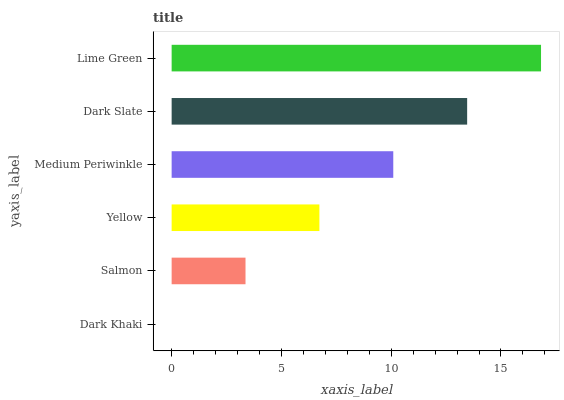Is Dark Khaki the minimum?
Answer yes or no. Yes. Is Lime Green the maximum?
Answer yes or no. Yes. Is Salmon the minimum?
Answer yes or no. No. Is Salmon the maximum?
Answer yes or no. No. Is Salmon greater than Dark Khaki?
Answer yes or no. Yes. Is Dark Khaki less than Salmon?
Answer yes or no. Yes. Is Dark Khaki greater than Salmon?
Answer yes or no. No. Is Salmon less than Dark Khaki?
Answer yes or no. No. Is Medium Periwinkle the high median?
Answer yes or no. Yes. Is Yellow the low median?
Answer yes or no. Yes. Is Dark Slate the high median?
Answer yes or no. No. Is Dark Khaki the low median?
Answer yes or no. No. 